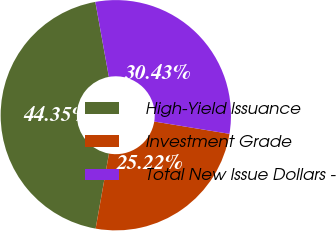<chart> <loc_0><loc_0><loc_500><loc_500><pie_chart><fcel>High-Yield Issuance<fcel>Investment Grade<fcel>Total New Issue Dollars -<nl><fcel>44.35%<fcel>25.22%<fcel>30.43%<nl></chart> 